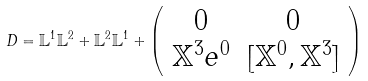Convert formula to latex. <formula><loc_0><loc_0><loc_500><loc_500>D = \mathbb { L } ^ { 1 } \mathbb { L } ^ { 2 } + \mathbb { L } ^ { 2 } \mathbb { L } ^ { 1 } + \left ( \begin{array} { c c } 0 & 0 \\ \mathbb { X } ^ { 3 } e ^ { 0 } & [ \mathbb { X } ^ { 0 } , \mathbb { X } ^ { 3 } ] \end{array} \right )</formula> 